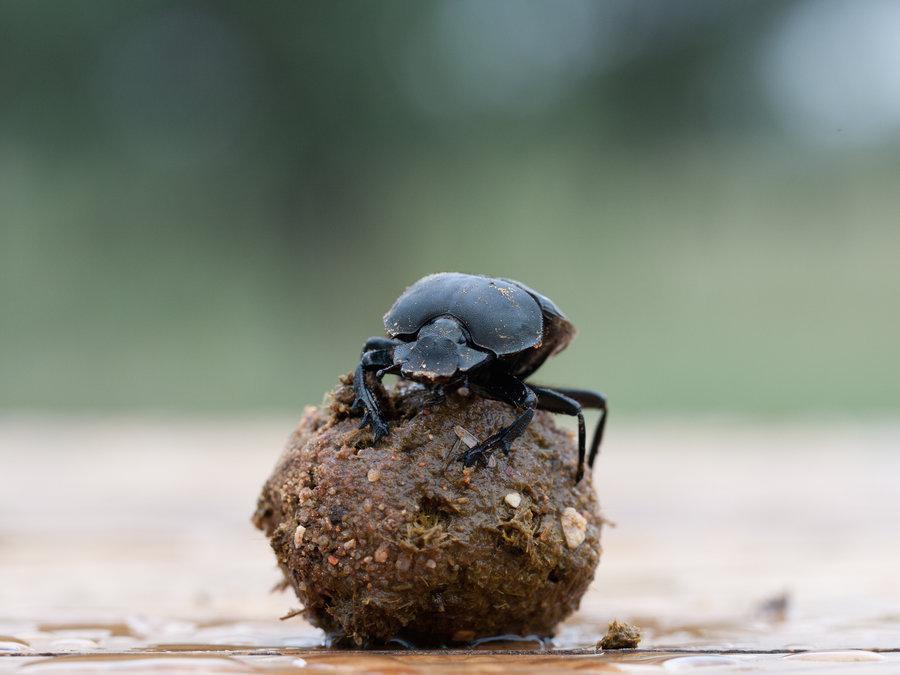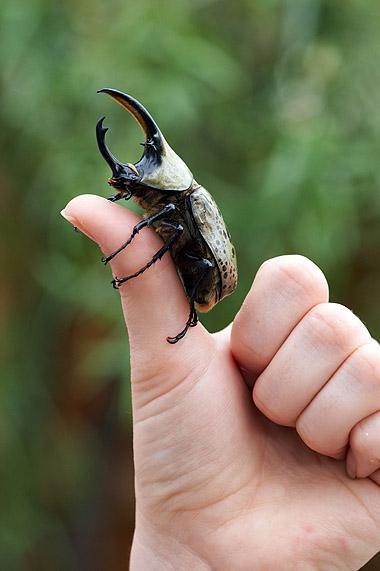The first image is the image on the left, the second image is the image on the right. Examine the images to the left and right. Is the description "A beetle crawls on a persons hand in the image on the right." accurate? Answer yes or no. Yes. The first image is the image on the left, the second image is the image on the right. Given the left and right images, does the statement "The right image has a beetle crawling on a persons hand." hold true? Answer yes or no. Yes. 